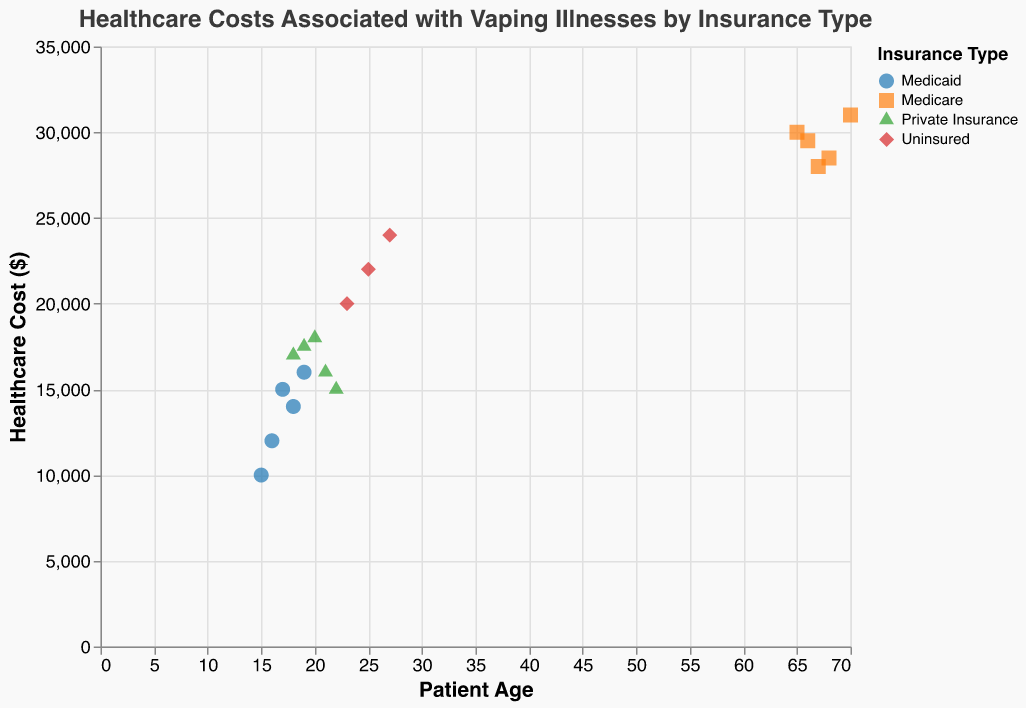What is the title of the figure? The title is displayed at the top of the figure and states the name of the analysis. The exact text of the title is "Healthcare Costs Associated with Vaping Illnesses by Insurance Type".
Answer: Healthcare Costs Associated with Vaping Illnesses by Insurance Type What variables are plotted on the x and y axes? The x-axis is labeled "Patient Age," indicating the age of patients. The y-axis is labeled "Healthcare Cost ($)," representing the healthcare costs in dollars associated with vaping illnesses.
Answer: Patient Age (x-axis), Healthcare Cost ($) (y-axis) Which insurance type generally has the highest healthcare costs? By looking at the grouping and positioning of data points for each insurance type along the y-axis, Medicare patients generally have the highest healthcare costs as their data points are positioned higher on the y-axis compared to other insurance types.
Answer: Medicare What is the range of healthcare costs for Medicaid patients? Observing the vertical spread of the Medicaid data points along the y-axis, the lowest cost is at $10,000 and the highest is at $16,000.
Answer: $10,000 to $16,000 Is there any insurance type that covers patients of all ages? Looking at the spread of data points across different patient ages for each insurance type, Medicaid covers patients aged 15 to 19, Private Insurance covers ages 18 to 22, Medicare covers ages 65 to 70, and Uninsured covers ages 23 to 27. There is no single insurance type that spans all age groups.
Answer: No What is the average healthcare cost for uninsured patients? Adding the healthcare costs of uninsured patients ($22,000 + $24,000 + $20,000) equals $66,000. Dividing by the number of data points (3) results in an average cost of $66,000/3 = $22,000.
Answer: $22,000 Compare the healthcare costs for the youngest Private Insurance patient and the youngest Uninsured patient. The youngest Private Insurance patient is aged 18 with a healthcare cost of $17,000. The youngest Uninsured patient is aged 23 with a healthcare cost of $20,000. Comparing these values, the uninsured patient has a higher cost.
Answer: Uninsured Which age group has the lowest and highest healthcare costs for Medicare patients? For Medicare patients, the lowest healthcare cost ($28,000) is seen at age 67. The highest healthcare cost ($31,000) is seen at age 70.
Answer: Age 67 (lowest), Age 70 (highest) Does any specific insurance type have a consistent healthcare cost range without outliers? Medicaid’s healthcare cost ranges from $10,000 to $16,000 and doesn't show any significant outliers, whereas other insurance types have wider ranges or visible outliers.
Answer: Medicaid 